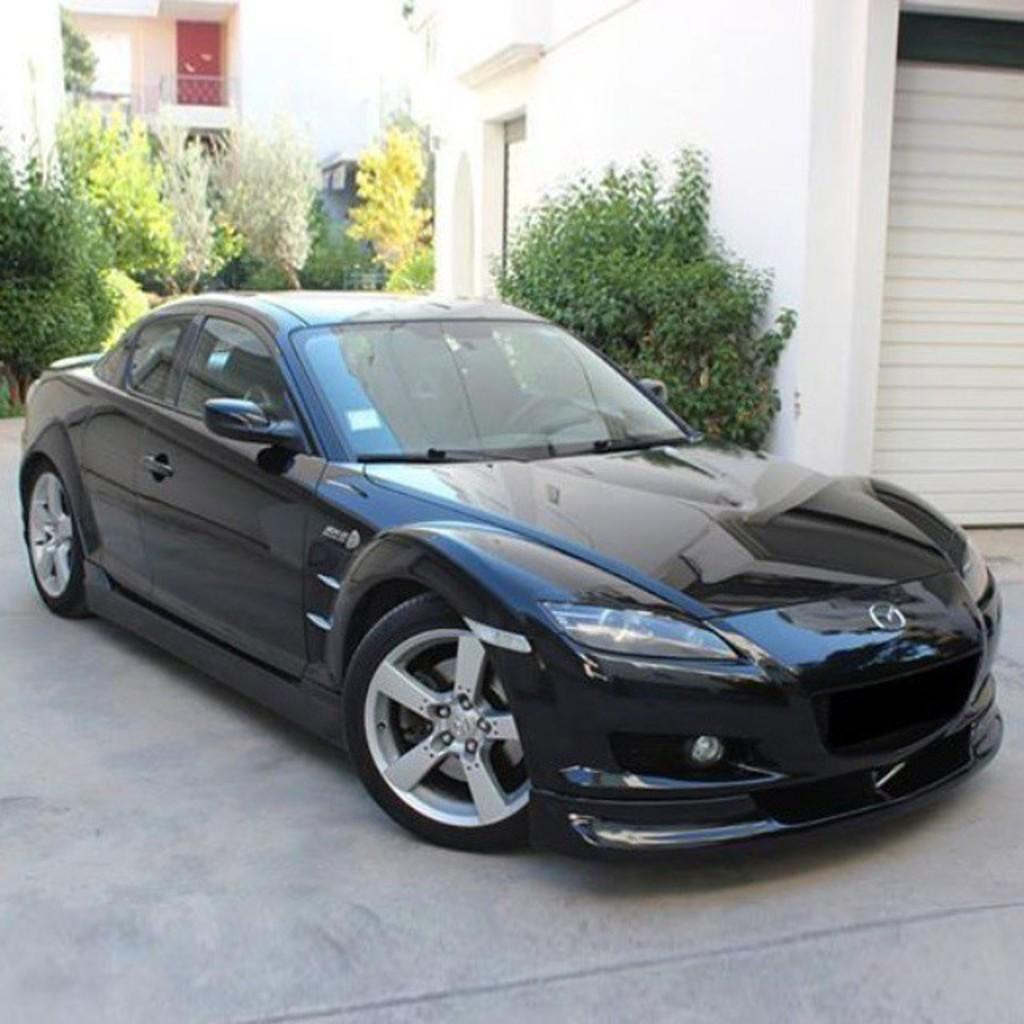What is the main subject in the foreground of the image? There is a car in the foreground of the image. What can be seen in the background of the image? There are buildings, trees, and plants in the background of the image. Can you see the maid feeding the robin with her hands in the image? There is no maid, robin, or hands present in the image. 